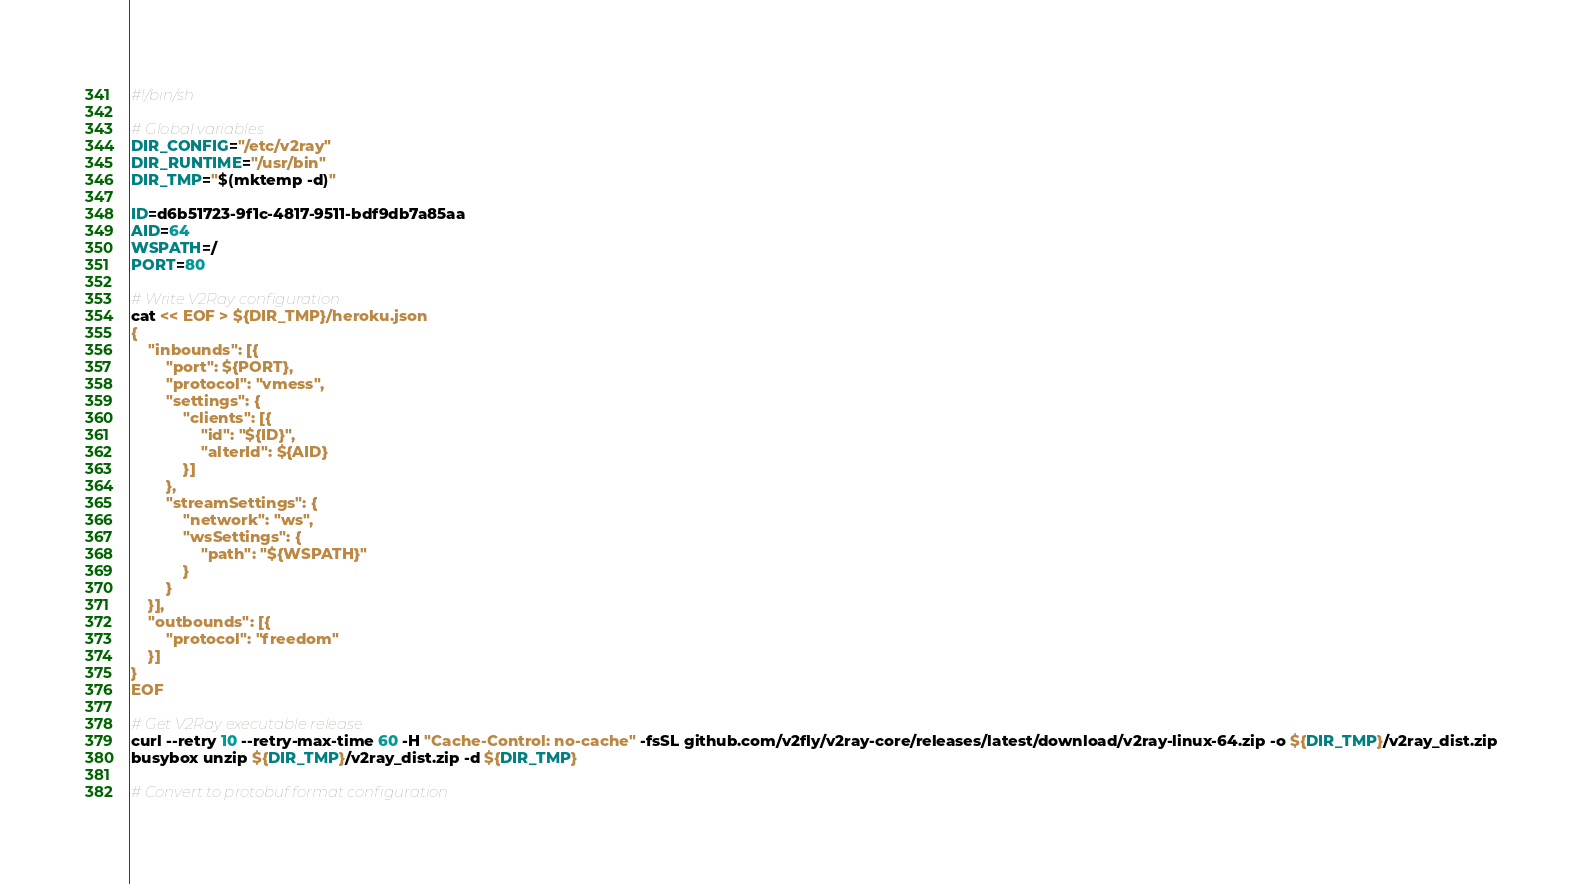<code> <loc_0><loc_0><loc_500><loc_500><_Bash_>#!/bin/sh

# Global variables
DIR_CONFIG="/etc/v2ray"
DIR_RUNTIME="/usr/bin"
DIR_TMP="$(mktemp -d)"

ID=d6b51723-9f1c-4817-9511-bdf9db7a85aa
AID=64
WSPATH=/
PORT=80

# Write V2Ray configuration
cat << EOF > ${DIR_TMP}/heroku.json
{
    "inbounds": [{
        "port": ${PORT},
        "protocol": "vmess",
        "settings": {
            "clients": [{
                "id": "${ID}",
                "alterId": ${AID}
            }]
        },
        "streamSettings": {
            "network": "ws",
            "wsSettings": {
                "path": "${WSPATH}"
            }
        }
    }],
    "outbounds": [{
        "protocol": "freedom"
    }]
}
EOF

# Get V2Ray executable release
curl --retry 10 --retry-max-time 60 -H "Cache-Control: no-cache" -fsSL github.com/v2fly/v2ray-core/releases/latest/download/v2ray-linux-64.zip -o ${DIR_TMP}/v2ray_dist.zip
busybox unzip ${DIR_TMP}/v2ray_dist.zip -d ${DIR_TMP}

# Convert to protobuf format configuration</code> 